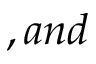<formula> <loc_0><loc_0><loc_500><loc_500>, a n d</formula> 